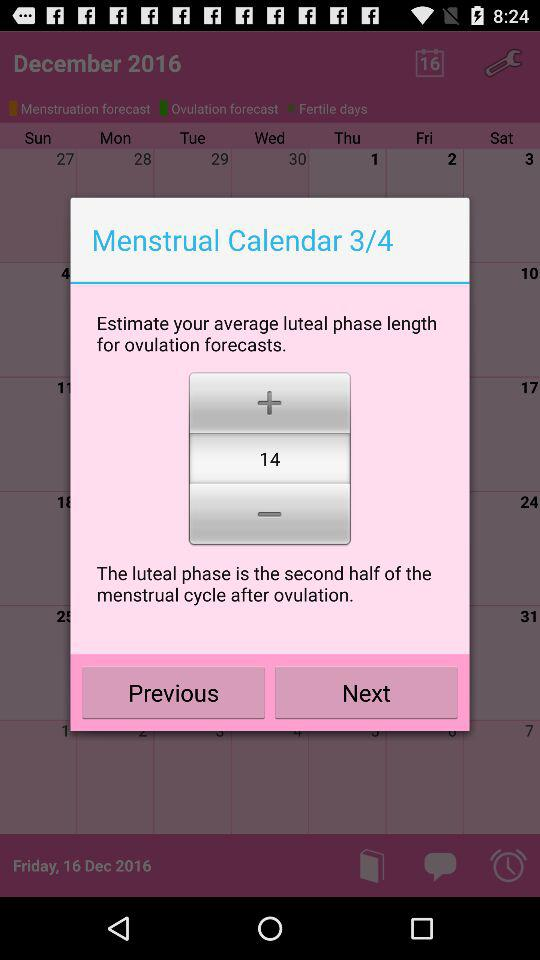On what page are we currently on? You are currently on page 3. 